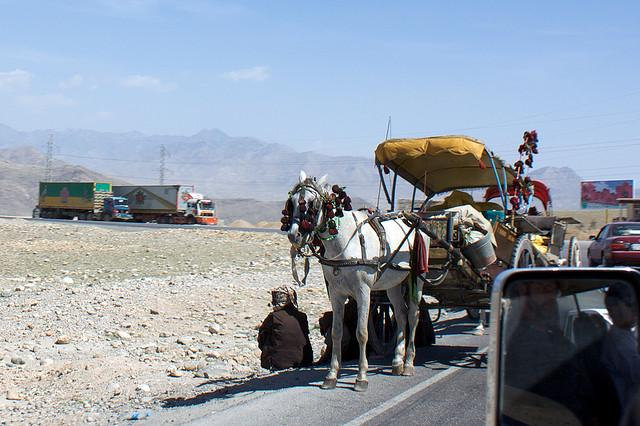In which continent is this road located? Please explain your reasoning. western asia. By looking at the horse and carriage it looks to be in asia. 